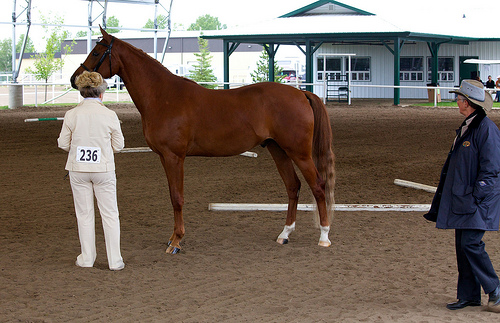<image>
Is there a horse under the shade? No. The horse is not positioned under the shade. The vertical relationship between these objects is different. 